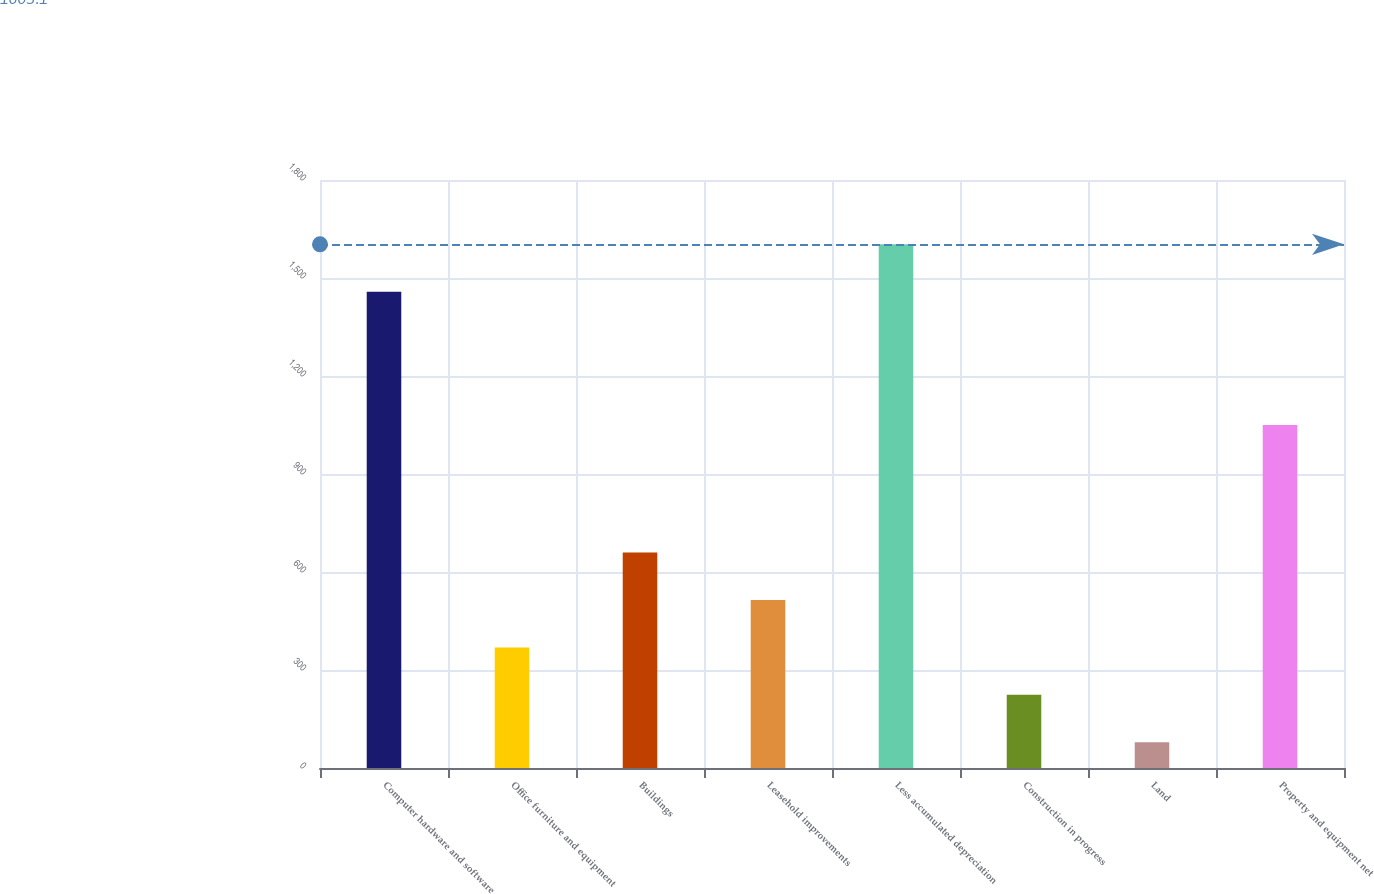Convert chart to OTSL. <chart><loc_0><loc_0><loc_500><loc_500><bar_chart><fcel>Computer hardware and software<fcel>Office furniture and equipment<fcel>Buildings<fcel>Leasehold improvements<fcel>Less accumulated depreciation<fcel>Construction in progress<fcel>Land<fcel>Property and equipment net<nl><fcel>1458<fcel>369.2<fcel>659.4<fcel>514.3<fcel>1603.1<fcel>224.1<fcel>79<fcel>1050<nl></chart> 